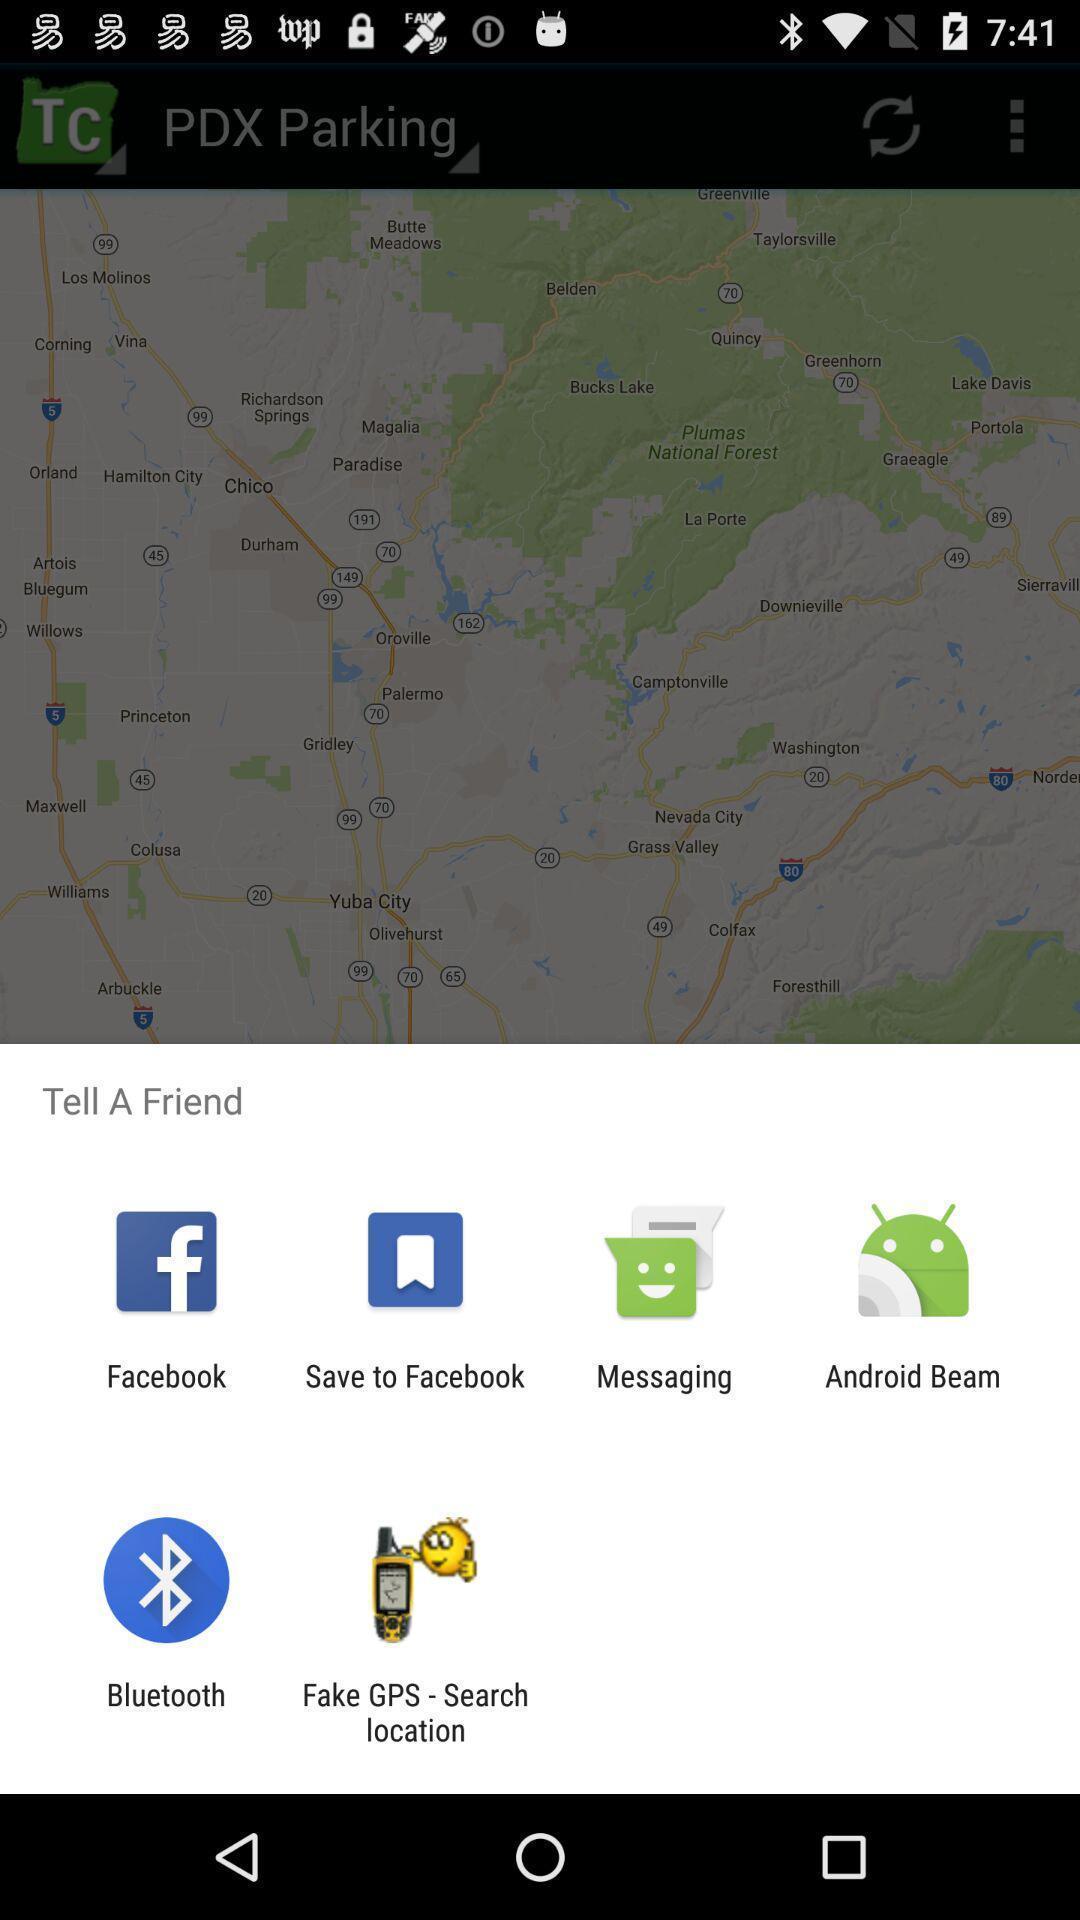Give me a narrative description of this picture. Pop-up displaying list of apps to select. 